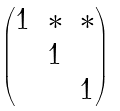<formula> <loc_0><loc_0><loc_500><loc_500>\begin{pmatrix} 1 & * & * \\ & 1 & \\ & & 1 \end{pmatrix}</formula> 